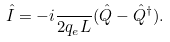Convert formula to latex. <formula><loc_0><loc_0><loc_500><loc_500>\hat { I } = - i \frac { } { 2 q _ { e } L } ( \hat { Q } - \hat { Q } ^ { \dagger } ) .</formula> 